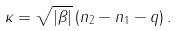<formula> <loc_0><loc_0><loc_500><loc_500>\kappa = \sqrt { | \beta | } \, ( n _ { 2 } - n _ { 1 } - q ) \, .</formula> 